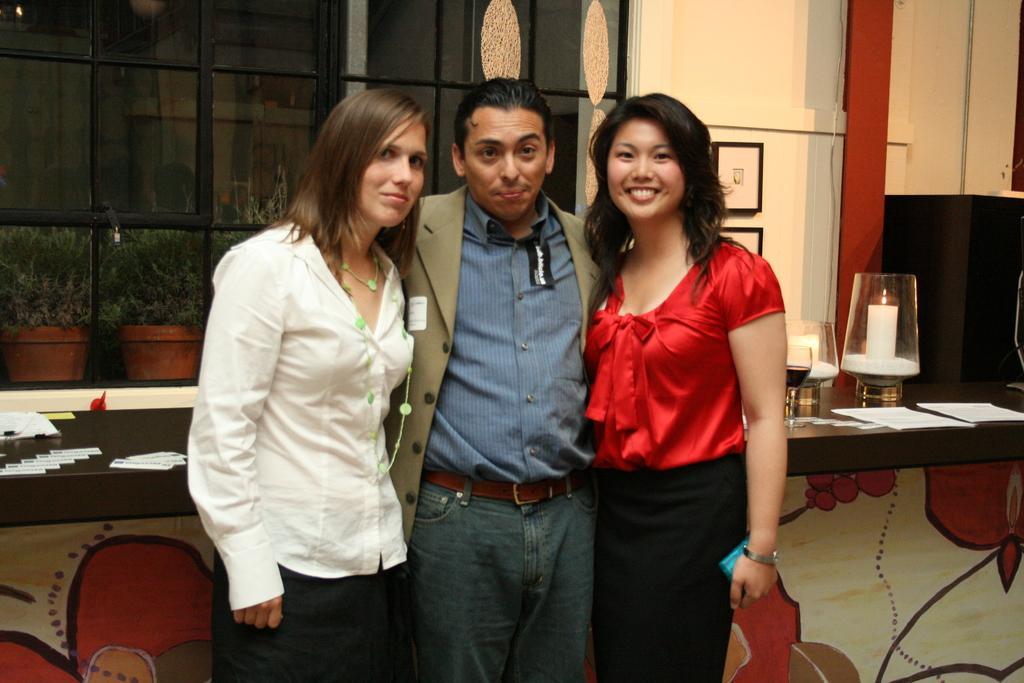Describe this image in one or two sentences. There is a man and two women standing in the foreground area of the image, there are papers and other objects on the desk behind them, it seems like there are windows, plants, frames and candles in the background and painting on a wall. 